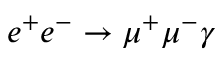<formula> <loc_0><loc_0><loc_500><loc_500>e ^ { + } e ^ { - } \rightarrow \mu ^ { + } \mu ^ { - } \gamma</formula> 